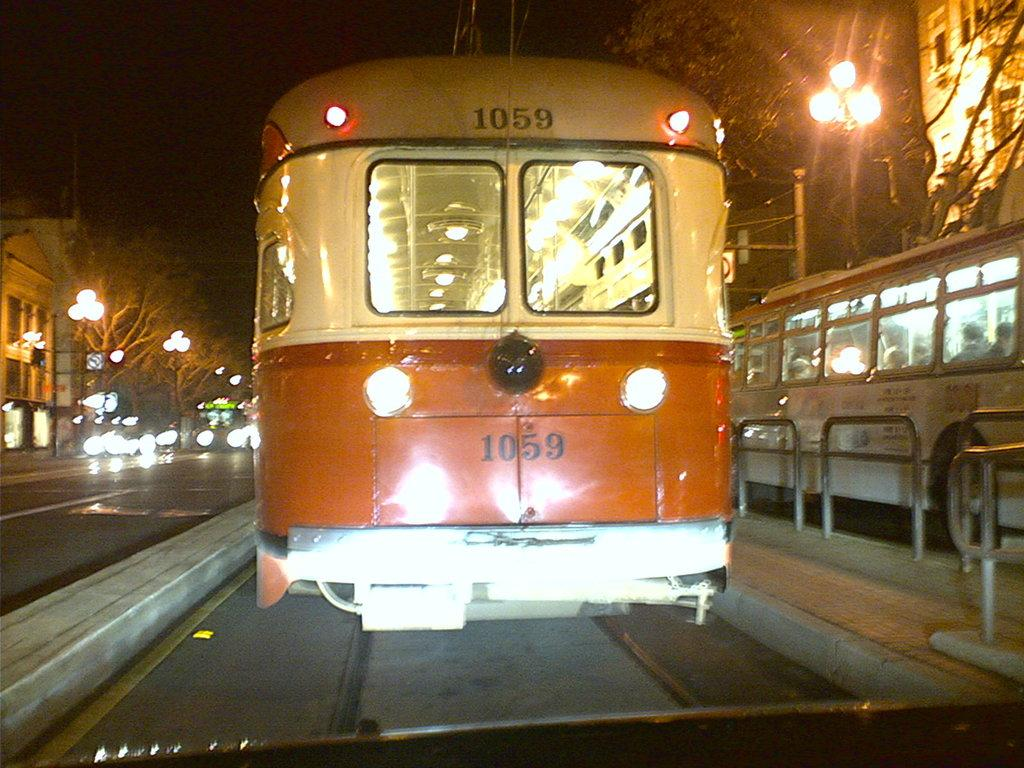What can be seen in the image related to transportation? There are vehicles in the image. What is located beside the vehicles? There is a barrier beside the vehicles. What type of vegetation is visible behind the vehicles? There is a group of trees behind the vehicles. What can be seen in the distance in the image? There are buildings visible in the background. What type of infrastructure is present in the background? Street poles with lights are present in the background. Can you describe the ocean visible in the image? There is no ocean present in the image. What type of butter is being used by the vehicles in the image? There is no butter present in the image; it features vehicles, a barrier, trees, buildings, and street poles with lights. 